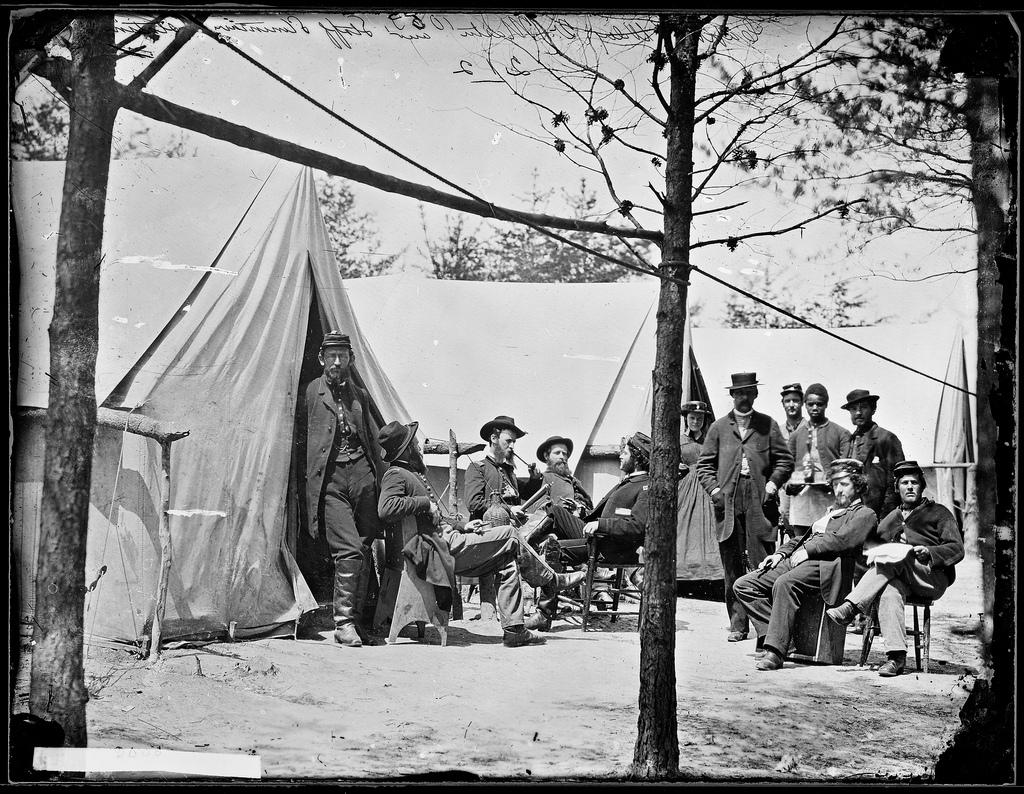What is the color scheme of the image? The image is black and white. What can be seen in the image? There are people in the image, some of whom are sitting and others standing. What structures are present in the image? There are tents in the image. What can be seen in the background of the image? There are trees and the sky visible in the background of the image. What type of hole can be seen in the image? There is no hole present in the image. Is there a ship visible in the image? No, there is no ship present in the image. 